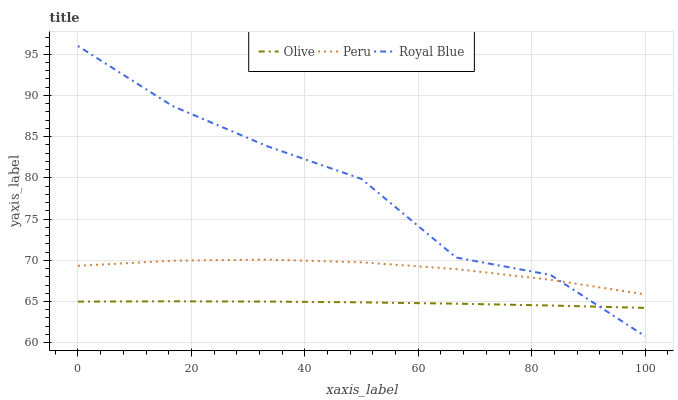Does Olive have the minimum area under the curve?
Answer yes or no. Yes. Does Royal Blue have the maximum area under the curve?
Answer yes or no. Yes. Does Peru have the minimum area under the curve?
Answer yes or no. No. Does Peru have the maximum area under the curve?
Answer yes or no. No. Is Olive the smoothest?
Answer yes or no. Yes. Is Royal Blue the roughest?
Answer yes or no. Yes. Is Peru the smoothest?
Answer yes or no. No. Is Peru the roughest?
Answer yes or no. No. Does Royal Blue have the lowest value?
Answer yes or no. Yes. Does Peru have the lowest value?
Answer yes or no. No. Does Royal Blue have the highest value?
Answer yes or no. Yes. Does Peru have the highest value?
Answer yes or no. No. Is Olive less than Peru?
Answer yes or no. Yes. Is Peru greater than Olive?
Answer yes or no. Yes. Does Royal Blue intersect Peru?
Answer yes or no. Yes. Is Royal Blue less than Peru?
Answer yes or no. No. Is Royal Blue greater than Peru?
Answer yes or no. No. Does Olive intersect Peru?
Answer yes or no. No. 